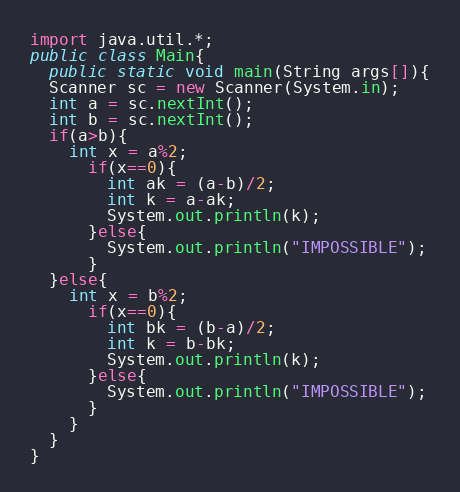<code> <loc_0><loc_0><loc_500><loc_500><_Java_>import java.util.*;
public class Main{
  public static void main(String args[]){
  Scanner sc = new Scanner(System.in);
  int a = sc.nextInt();
  int b = sc.nextInt();
  if(a>b){
    int x = a%2;
      if(x==0){
        int ak = (a-b)/2;
        int k = a-ak;
        System.out.println(k);
      }else{
        System.out.println("IMPOSSIBLE");
      }
  }else{
    int x = b%2;
      if(x==0){
        int bk = (b-a)/2;
        int k = b-bk;
        System.out.println(k);
      }else{
        System.out.println("IMPOSSIBLE");
      }
    }
  }
}</code> 